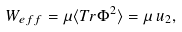Convert formula to latex. <formula><loc_0><loc_0><loc_500><loc_500>W _ { e f f } = \mu \langle T r \Phi ^ { 2 } \rangle = \mu \, u _ { 2 } ,</formula> 